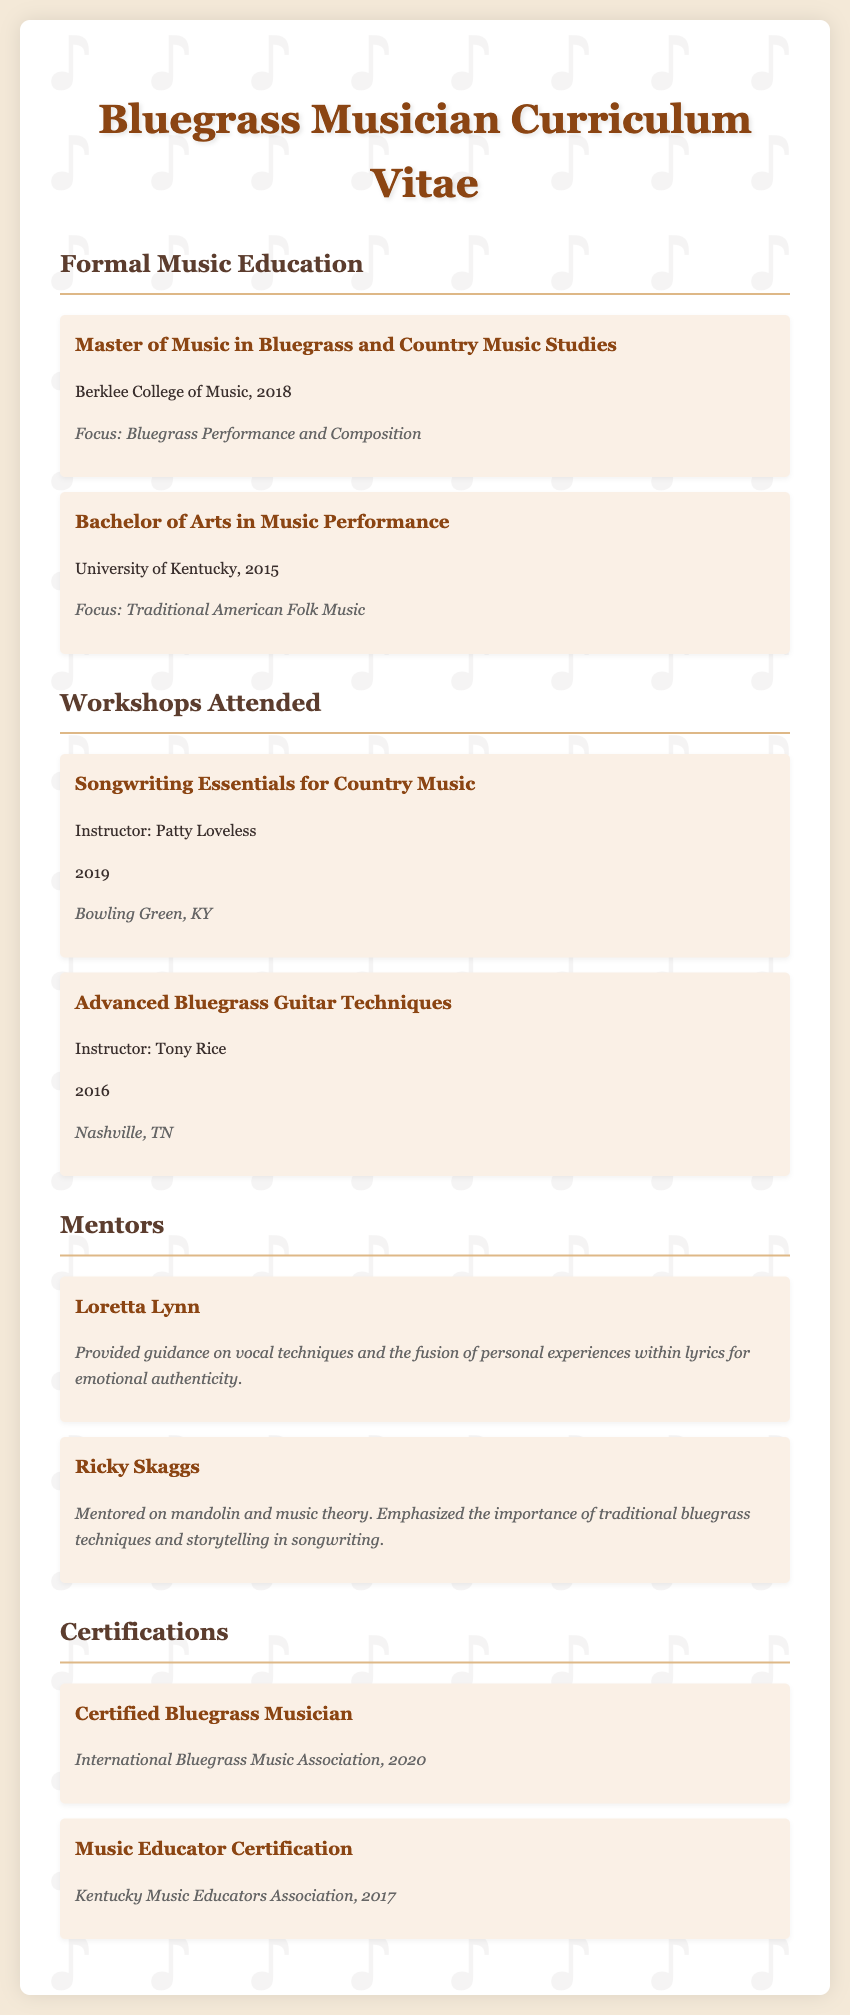What degree did you earn at Berklee College of Music? The document states that the individual earned a Master of Music in Bluegrass and Country Music Studies at Berklee College of Music in 2018.
Answer: Master of Music in Bluegrass and Country Music Studies Who was the instructor for the workshop on Advanced Bluegrass Guitar Techniques? The document lists Tony Rice as the instructor for the workshop held in 2016.
Answer: Tony Rice What year did you receive the Certified Bluegrass Musician certification? According to the document, the certification was earned in 2020.
Answer: 2020 Which mentor provided guidance on vocal techniques? The document identifies Loretta Lynn as the mentor who provided guidance on vocal techniques.
Answer: Loretta Lynn What focus did you have during your Bachelor of Arts? The document indicates that the focus was on Traditional American Folk Music.
Answer: Traditional American Folk Music In what location was the Songwriting Essentials for Country Music workshop held? The document specifies that the workshop took place in Bowling Green, KY.
Answer: Bowling Green, KY How many certifications are listed in the document? The document includes two certifications earned by the individual.
Answer: Two What is the focus area of your Master's degree? The document states the focus area as Bluegrass Performance and Composition.
Answer: Bluegrass Performance and Composition What influential aspect did Ricky Skaggs emphasize in his mentorship? The document notes that Ricky Skaggs emphasized the importance of traditional bluegrass techniques and storytelling in songwriting.
Answer: Traditional bluegrass techniques and storytelling 